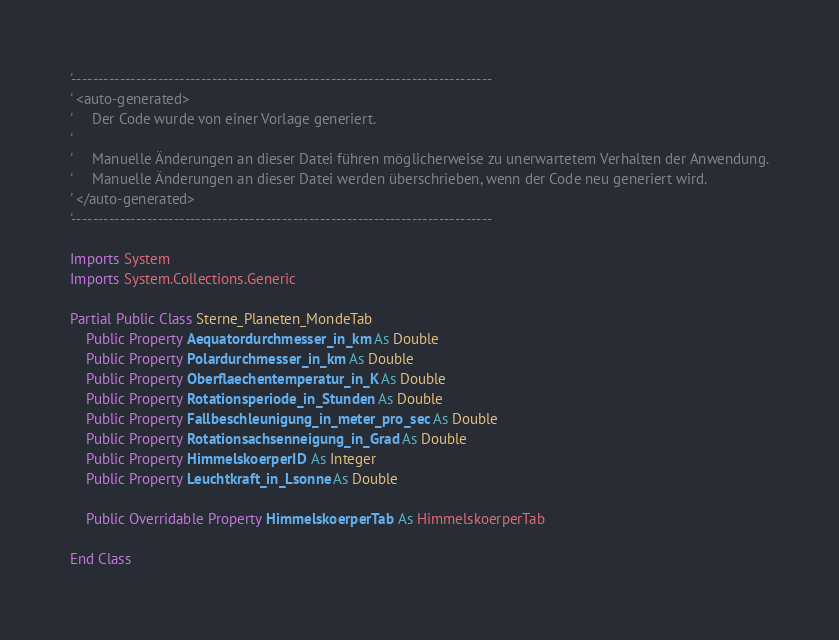Convert code to text. <code><loc_0><loc_0><loc_500><loc_500><_VisualBasic_>'------------------------------------------------------------------------------
' <auto-generated>
'     Der Code wurde von einer Vorlage generiert.
'
'     Manuelle Änderungen an dieser Datei führen möglicherweise zu unerwartetem Verhalten der Anwendung.
'     Manuelle Änderungen an dieser Datei werden überschrieben, wenn der Code neu generiert wird.
' </auto-generated>
'------------------------------------------------------------------------------

Imports System
Imports System.Collections.Generic

Partial Public Class Sterne_Planeten_MondeTab
    Public Property Aequatordurchmesser_in_km As Double
    Public Property Polardurchmesser_in_km As Double
    Public Property Oberflaechentemperatur_in_K As Double
    Public Property Rotationsperiode_in_Stunden As Double
    Public Property Fallbeschleunigung_in_meter_pro_sec As Double
    Public Property Rotationsachsenneigung_in_Grad As Double
    Public Property HimmelskoerperID As Integer
    Public Property Leuchtkraft_in_Lsonne As Double

    Public Overridable Property HimmelskoerperTab As HimmelskoerperTab

End Class
</code> 